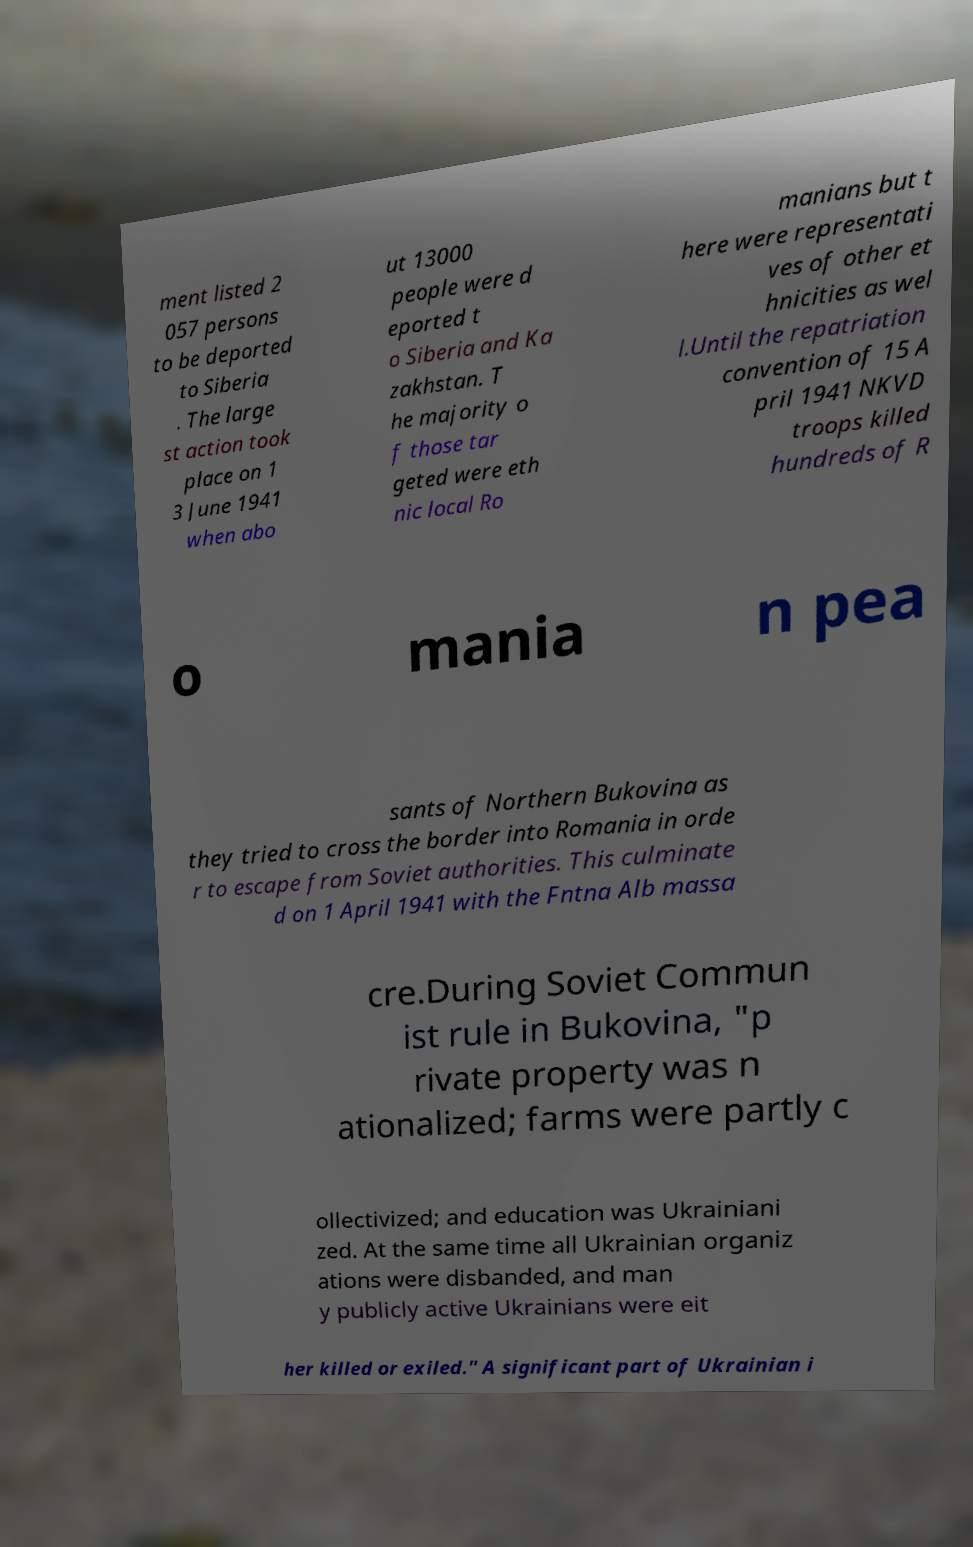Please identify and transcribe the text found in this image. ment listed 2 057 persons to be deported to Siberia . The large st action took place on 1 3 June 1941 when abo ut 13000 people were d eported t o Siberia and Ka zakhstan. T he majority o f those tar geted were eth nic local Ro manians but t here were representati ves of other et hnicities as wel l.Until the repatriation convention of 15 A pril 1941 NKVD troops killed hundreds of R o mania n pea sants of Northern Bukovina as they tried to cross the border into Romania in orde r to escape from Soviet authorities. This culminate d on 1 April 1941 with the Fntna Alb massa cre.During Soviet Commun ist rule in Bukovina, "p rivate property was n ationalized; farms were partly c ollectivized; and education was Ukrainiani zed. At the same time all Ukrainian organiz ations were disbanded, and man y publicly active Ukrainians were eit her killed or exiled." A significant part of Ukrainian i 